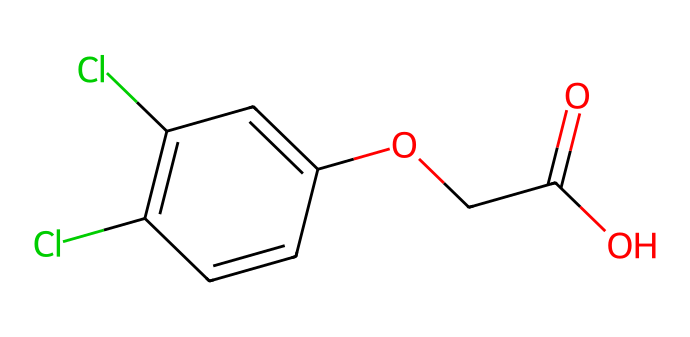What is the total number of carbon atoms in 2,4-Dichlorophenoxyacetic acid? The SMILES representation indicates that there are a total of 8 carbon atoms. This can be counted directly from the structure in the SMILES.
Answer: 8 How many chlorine atoms are present in this herbicide? From the SMILES, there are 2 chlorine atoms present, specifically indicated by the 'Cl' notation.
Answer: 2 What functional group is present in 2,4-Dichlorophenoxyacetic acid? The structure shows the presence of a carboxylic acid functional group, which is denoted by the 'C(=O)O' in the SMILES.
Answer: carboxylic acid What type of bonding is mainly responsible for the herbicidal activity of 2,4-Dichlorophenoxyacetic acid? The herbicidal activity is primarily due to the structure's interactions, which suggest that it acts as a synthetic auxin, promoting unnatural growth in plants. This is facilitated through non-covalent interactions including hydrogen bonding and ionic interactions.
Answer: synthetic auxin How does the presence of chlorines affect the herbicide's effectiveness? The chlorine atoms increase the herbicide's lipophilicity and stability, which enhances its ability to penetrate plant tissues and disrupt growth processes leading to effective herbicidal action.
Answer: increases effectiveness What type of herbicide is 2,4-Dichlorophenoxyacetic acid classified as? This chemical is classified as a selective herbicide, meaning that it targets certain types of plants while leaving others unharmed.
Answer: selective herbicide 